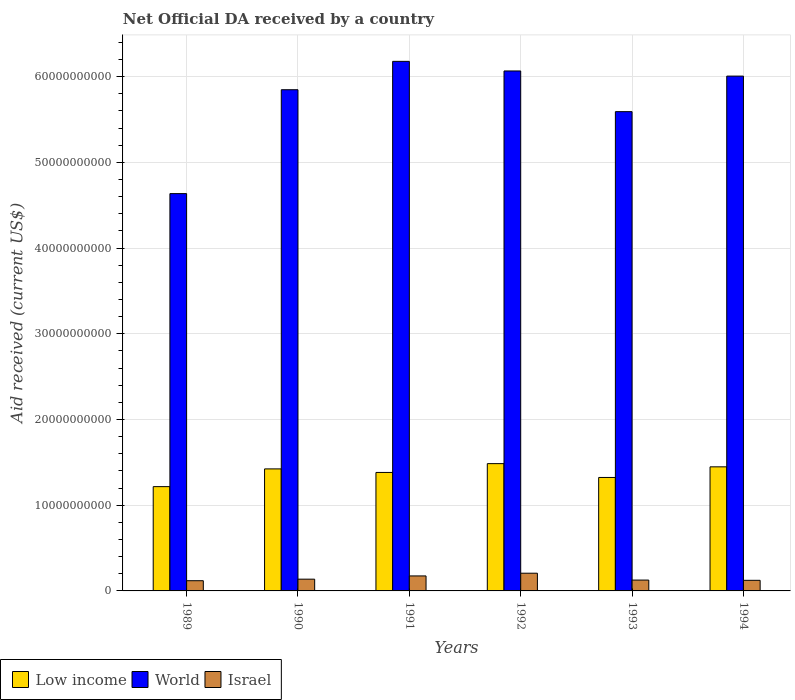How many different coloured bars are there?
Provide a succinct answer. 3. How many groups of bars are there?
Your answer should be very brief. 6. Are the number of bars on each tick of the X-axis equal?
Your answer should be compact. Yes. How many bars are there on the 5th tick from the left?
Provide a succinct answer. 3. How many bars are there on the 3rd tick from the right?
Offer a terse response. 3. In how many cases, is the number of bars for a given year not equal to the number of legend labels?
Your answer should be compact. 0. What is the net official development assistance aid received in Israel in 1991?
Give a very brief answer. 1.75e+09. Across all years, what is the maximum net official development assistance aid received in World?
Your answer should be compact. 6.18e+1. Across all years, what is the minimum net official development assistance aid received in World?
Make the answer very short. 4.64e+1. What is the total net official development assistance aid received in World in the graph?
Offer a very short reply. 3.43e+11. What is the difference between the net official development assistance aid received in World in 1990 and that in 1993?
Give a very brief answer. 2.56e+09. What is the difference between the net official development assistance aid received in Low income in 1991 and the net official development assistance aid received in Israel in 1994?
Your response must be concise. 1.26e+1. What is the average net official development assistance aid received in World per year?
Your answer should be compact. 5.72e+1. In the year 1994, what is the difference between the net official development assistance aid received in Israel and net official development assistance aid received in World?
Provide a succinct answer. -5.88e+1. In how many years, is the net official development assistance aid received in Low income greater than 62000000000 US$?
Provide a succinct answer. 0. What is the ratio of the net official development assistance aid received in Low income in 1989 to that in 1993?
Provide a succinct answer. 0.92. What is the difference between the highest and the second highest net official development assistance aid received in World?
Keep it short and to the point. 1.12e+09. What is the difference between the highest and the lowest net official development assistance aid received in Israel?
Your response must be concise. 8.74e+08. In how many years, is the net official development assistance aid received in World greater than the average net official development assistance aid received in World taken over all years?
Offer a terse response. 4. Is it the case that in every year, the sum of the net official development assistance aid received in World and net official development assistance aid received in Low income is greater than the net official development assistance aid received in Israel?
Offer a very short reply. Yes. Are all the bars in the graph horizontal?
Provide a succinct answer. No. How many years are there in the graph?
Your answer should be compact. 6. Are the values on the major ticks of Y-axis written in scientific E-notation?
Make the answer very short. No. Does the graph contain grids?
Your answer should be very brief. Yes. How are the legend labels stacked?
Offer a very short reply. Horizontal. What is the title of the graph?
Make the answer very short. Net Official DA received by a country. Does "Sao Tome and Principe" appear as one of the legend labels in the graph?
Offer a very short reply. No. What is the label or title of the X-axis?
Provide a short and direct response. Years. What is the label or title of the Y-axis?
Offer a terse response. Aid received (current US$). What is the Aid received (current US$) of Low income in 1989?
Give a very brief answer. 1.22e+1. What is the Aid received (current US$) in World in 1989?
Make the answer very short. 4.64e+1. What is the Aid received (current US$) in Israel in 1989?
Offer a very short reply. 1.19e+09. What is the Aid received (current US$) in Low income in 1990?
Offer a terse response. 1.42e+1. What is the Aid received (current US$) in World in 1990?
Keep it short and to the point. 5.85e+1. What is the Aid received (current US$) in Israel in 1990?
Provide a short and direct response. 1.37e+09. What is the Aid received (current US$) in Low income in 1991?
Your answer should be very brief. 1.38e+1. What is the Aid received (current US$) of World in 1991?
Your answer should be very brief. 6.18e+1. What is the Aid received (current US$) of Israel in 1991?
Ensure brevity in your answer.  1.75e+09. What is the Aid received (current US$) in Low income in 1992?
Make the answer very short. 1.49e+1. What is the Aid received (current US$) of World in 1992?
Make the answer very short. 6.07e+1. What is the Aid received (current US$) in Israel in 1992?
Your answer should be very brief. 2.07e+09. What is the Aid received (current US$) of Low income in 1993?
Provide a short and direct response. 1.32e+1. What is the Aid received (current US$) of World in 1993?
Your answer should be compact. 5.59e+1. What is the Aid received (current US$) of Israel in 1993?
Your answer should be very brief. 1.27e+09. What is the Aid received (current US$) of Low income in 1994?
Provide a short and direct response. 1.45e+1. What is the Aid received (current US$) in World in 1994?
Offer a very short reply. 6.01e+1. What is the Aid received (current US$) of Israel in 1994?
Your answer should be very brief. 1.24e+09. Across all years, what is the maximum Aid received (current US$) in Low income?
Keep it short and to the point. 1.49e+1. Across all years, what is the maximum Aid received (current US$) in World?
Ensure brevity in your answer.  6.18e+1. Across all years, what is the maximum Aid received (current US$) of Israel?
Make the answer very short. 2.07e+09. Across all years, what is the minimum Aid received (current US$) in Low income?
Your answer should be very brief. 1.22e+1. Across all years, what is the minimum Aid received (current US$) in World?
Give a very brief answer. 4.64e+1. Across all years, what is the minimum Aid received (current US$) in Israel?
Your answer should be very brief. 1.19e+09. What is the total Aid received (current US$) in Low income in the graph?
Offer a very short reply. 8.28e+1. What is the total Aid received (current US$) of World in the graph?
Offer a very short reply. 3.43e+11. What is the total Aid received (current US$) of Israel in the graph?
Provide a short and direct response. 8.88e+09. What is the difference between the Aid received (current US$) of Low income in 1989 and that in 1990?
Provide a short and direct response. -2.07e+09. What is the difference between the Aid received (current US$) of World in 1989 and that in 1990?
Your answer should be compact. -1.21e+1. What is the difference between the Aid received (current US$) in Israel in 1989 and that in 1990?
Ensure brevity in your answer.  -1.80e+08. What is the difference between the Aid received (current US$) of Low income in 1989 and that in 1991?
Offer a terse response. -1.66e+09. What is the difference between the Aid received (current US$) in World in 1989 and that in 1991?
Provide a short and direct response. -1.54e+1. What is the difference between the Aid received (current US$) of Israel in 1989 and that in 1991?
Your answer should be compact. -5.58e+08. What is the difference between the Aid received (current US$) in Low income in 1989 and that in 1992?
Ensure brevity in your answer.  -2.68e+09. What is the difference between the Aid received (current US$) in World in 1989 and that in 1992?
Ensure brevity in your answer.  -1.43e+1. What is the difference between the Aid received (current US$) in Israel in 1989 and that in 1992?
Ensure brevity in your answer.  -8.74e+08. What is the difference between the Aid received (current US$) of Low income in 1989 and that in 1993?
Your answer should be very brief. -1.07e+09. What is the difference between the Aid received (current US$) of World in 1989 and that in 1993?
Keep it short and to the point. -9.57e+09. What is the difference between the Aid received (current US$) of Israel in 1989 and that in 1993?
Provide a short and direct response. -7.44e+07. What is the difference between the Aid received (current US$) in Low income in 1989 and that in 1994?
Ensure brevity in your answer.  -2.31e+09. What is the difference between the Aid received (current US$) in World in 1989 and that in 1994?
Offer a terse response. -1.37e+1. What is the difference between the Aid received (current US$) in Israel in 1989 and that in 1994?
Offer a terse response. -4.54e+07. What is the difference between the Aid received (current US$) in Low income in 1990 and that in 1991?
Give a very brief answer. 4.14e+08. What is the difference between the Aid received (current US$) in World in 1990 and that in 1991?
Your answer should be compact. -3.31e+09. What is the difference between the Aid received (current US$) of Israel in 1990 and that in 1991?
Your answer should be compact. -3.78e+08. What is the difference between the Aid received (current US$) in Low income in 1990 and that in 1992?
Make the answer very short. -6.16e+08. What is the difference between the Aid received (current US$) of World in 1990 and that in 1992?
Offer a very short reply. -2.19e+09. What is the difference between the Aid received (current US$) of Israel in 1990 and that in 1992?
Offer a terse response. -6.94e+08. What is the difference between the Aid received (current US$) of Low income in 1990 and that in 1993?
Your answer should be compact. 9.98e+08. What is the difference between the Aid received (current US$) in World in 1990 and that in 1993?
Your response must be concise. 2.56e+09. What is the difference between the Aid received (current US$) of Israel in 1990 and that in 1993?
Your answer should be compact. 1.06e+08. What is the difference between the Aid received (current US$) of Low income in 1990 and that in 1994?
Offer a very short reply. -2.41e+08. What is the difference between the Aid received (current US$) of World in 1990 and that in 1994?
Provide a short and direct response. -1.59e+09. What is the difference between the Aid received (current US$) of Israel in 1990 and that in 1994?
Ensure brevity in your answer.  1.35e+08. What is the difference between the Aid received (current US$) of Low income in 1991 and that in 1992?
Keep it short and to the point. -1.03e+09. What is the difference between the Aid received (current US$) in World in 1991 and that in 1992?
Your answer should be very brief. 1.12e+09. What is the difference between the Aid received (current US$) of Israel in 1991 and that in 1992?
Provide a short and direct response. -3.16e+08. What is the difference between the Aid received (current US$) in Low income in 1991 and that in 1993?
Your answer should be very brief. 5.84e+08. What is the difference between the Aid received (current US$) of World in 1991 and that in 1993?
Keep it short and to the point. 5.87e+09. What is the difference between the Aid received (current US$) in Israel in 1991 and that in 1993?
Your answer should be very brief. 4.83e+08. What is the difference between the Aid received (current US$) of Low income in 1991 and that in 1994?
Provide a short and direct response. -6.55e+08. What is the difference between the Aid received (current US$) in World in 1991 and that in 1994?
Offer a very short reply. 1.72e+09. What is the difference between the Aid received (current US$) in Israel in 1991 and that in 1994?
Give a very brief answer. 5.12e+08. What is the difference between the Aid received (current US$) in Low income in 1992 and that in 1993?
Make the answer very short. 1.61e+09. What is the difference between the Aid received (current US$) of World in 1992 and that in 1993?
Provide a short and direct response. 4.75e+09. What is the difference between the Aid received (current US$) of Israel in 1992 and that in 1993?
Make the answer very short. 8.00e+08. What is the difference between the Aid received (current US$) in Low income in 1992 and that in 1994?
Provide a short and direct response. 3.74e+08. What is the difference between the Aid received (current US$) of World in 1992 and that in 1994?
Your response must be concise. 5.99e+08. What is the difference between the Aid received (current US$) in Israel in 1992 and that in 1994?
Make the answer very short. 8.29e+08. What is the difference between the Aid received (current US$) of Low income in 1993 and that in 1994?
Your answer should be very brief. -1.24e+09. What is the difference between the Aid received (current US$) in World in 1993 and that in 1994?
Make the answer very short. -4.15e+09. What is the difference between the Aid received (current US$) in Israel in 1993 and that in 1994?
Your answer should be very brief. 2.90e+07. What is the difference between the Aid received (current US$) in Low income in 1989 and the Aid received (current US$) in World in 1990?
Your response must be concise. -4.63e+1. What is the difference between the Aid received (current US$) of Low income in 1989 and the Aid received (current US$) of Israel in 1990?
Provide a succinct answer. 1.08e+1. What is the difference between the Aid received (current US$) in World in 1989 and the Aid received (current US$) in Israel in 1990?
Keep it short and to the point. 4.50e+1. What is the difference between the Aid received (current US$) in Low income in 1989 and the Aid received (current US$) in World in 1991?
Make the answer very short. -4.96e+1. What is the difference between the Aid received (current US$) of Low income in 1989 and the Aid received (current US$) of Israel in 1991?
Provide a succinct answer. 1.04e+1. What is the difference between the Aid received (current US$) in World in 1989 and the Aid received (current US$) in Israel in 1991?
Ensure brevity in your answer.  4.46e+1. What is the difference between the Aid received (current US$) in Low income in 1989 and the Aid received (current US$) in World in 1992?
Your response must be concise. -4.85e+1. What is the difference between the Aid received (current US$) of Low income in 1989 and the Aid received (current US$) of Israel in 1992?
Ensure brevity in your answer.  1.01e+1. What is the difference between the Aid received (current US$) in World in 1989 and the Aid received (current US$) in Israel in 1992?
Offer a terse response. 4.43e+1. What is the difference between the Aid received (current US$) in Low income in 1989 and the Aid received (current US$) in World in 1993?
Give a very brief answer. -4.38e+1. What is the difference between the Aid received (current US$) in Low income in 1989 and the Aid received (current US$) in Israel in 1993?
Keep it short and to the point. 1.09e+1. What is the difference between the Aid received (current US$) in World in 1989 and the Aid received (current US$) in Israel in 1993?
Ensure brevity in your answer.  4.51e+1. What is the difference between the Aid received (current US$) in Low income in 1989 and the Aid received (current US$) in World in 1994?
Your answer should be very brief. -4.79e+1. What is the difference between the Aid received (current US$) in Low income in 1989 and the Aid received (current US$) in Israel in 1994?
Make the answer very short. 1.09e+1. What is the difference between the Aid received (current US$) in World in 1989 and the Aid received (current US$) in Israel in 1994?
Provide a succinct answer. 4.51e+1. What is the difference between the Aid received (current US$) of Low income in 1990 and the Aid received (current US$) of World in 1991?
Offer a terse response. -4.76e+1. What is the difference between the Aid received (current US$) in Low income in 1990 and the Aid received (current US$) in Israel in 1991?
Keep it short and to the point. 1.25e+1. What is the difference between the Aid received (current US$) in World in 1990 and the Aid received (current US$) in Israel in 1991?
Ensure brevity in your answer.  5.67e+1. What is the difference between the Aid received (current US$) in Low income in 1990 and the Aid received (current US$) in World in 1992?
Give a very brief answer. -4.64e+1. What is the difference between the Aid received (current US$) of Low income in 1990 and the Aid received (current US$) of Israel in 1992?
Your answer should be very brief. 1.22e+1. What is the difference between the Aid received (current US$) of World in 1990 and the Aid received (current US$) of Israel in 1992?
Make the answer very short. 5.64e+1. What is the difference between the Aid received (current US$) of Low income in 1990 and the Aid received (current US$) of World in 1993?
Provide a succinct answer. -4.17e+1. What is the difference between the Aid received (current US$) in Low income in 1990 and the Aid received (current US$) in Israel in 1993?
Give a very brief answer. 1.30e+1. What is the difference between the Aid received (current US$) in World in 1990 and the Aid received (current US$) in Israel in 1993?
Your response must be concise. 5.72e+1. What is the difference between the Aid received (current US$) of Low income in 1990 and the Aid received (current US$) of World in 1994?
Your answer should be very brief. -4.58e+1. What is the difference between the Aid received (current US$) in Low income in 1990 and the Aid received (current US$) in Israel in 1994?
Provide a succinct answer. 1.30e+1. What is the difference between the Aid received (current US$) of World in 1990 and the Aid received (current US$) of Israel in 1994?
Your answer should be compact. 5.72e+1. What is the difference between the Aid received (current US$) in Low income in 1991 and the Aid received (current US$) in World in 1992?
Provide a succinct answer. -4.68e+1. What is the difference between the Aid received (current US$) in Low income in 1991 and the Aid received (current US$) in Israel in 1992?
Ensure brevity in your answer.  1.18e+1. What is the difference between the Aid received (current US$) of World in 1991 and the Aid received (current US$) of Israel in 1992?
Keep it short and to the point. 5.97e+1. What is the difference between the Aid received (current US$) in Low income in 1991 and the Aid received (current US$) in World in 1993?
Your answer should be very brief. -4.21e+1. What is the difference between the Aid received (current US$) in Low income in 1991 and the Aid received (current US$) in Israel in 1993?
Offer a very short reply. 1.26e+1. What is the difference between the Aid received (current US$) of World in 1991 and the Aid received (current US$) of Israel in 1993?
Give a very brief answer. 6.05e+1. What is the difference between the Aid received (current US$) of Low income in 1991 and the Aid received (current US$) of World in 1994?
Provide a succinct answer. -4.62e+1. What is the difference between the Aid received (current US$) in Low income in 1991 and the Aid received (current US$) in Israel in 1994?
Offer a terse response. 1.26e+1. What is the difference between the Aid received (current US$) in World in 1991 and the Aid received (current US$) in Israel in 1994?
Provide a short and direct response. 6.06e+1. What is the difference between the Aid received (current US$) in Low income in 1992 and the Aid received (current US$) in World in 1993?
Provide a succinct answer. -4.11e+1. What is the difference between the Aid received (current US$) of Low income in 1992 and the Aid received (current US$) of Israel in 1993?
Provide a succinct answer. 1.36e+1. What is the difference between the Aid received (current US$) in World in 1992 and the Aid received (current US$) in Israel in 1993?
Your answer should be compact. 5.94e+1. What is the difference between the Aid received (current US$) in Low income in 1992 and the Aid received (current US$) in World in 1994?
Provide a succinct answer. -4.52e+1. What is the difference between the Aid received (current US$) in Low income in 1992 and the Aid received (current US$) in Israel in 1994?
Your answer should be very brief. 1.36e+1. What is the difference between the Aid received (current US$) of World in 1992 and the Aid received (current US$) of Israel in 1994?
Provide a short and direct response. 5.94e+1. What is the difference between the Aid received (current US$) in Low income in 1993 and the Aid received (current US$) in World in 1994?
Ensure brevity in your answer.  -4.68e+1. What is the difference between the Aid received (current US$) in Low income in 1993 and the Aid received (current US$) in Israel in 1994?
Give a very brief answer. 1.20e+1. What is the difference between the Aid received (current US$) of World in 1993 and the Aid received (current US$) of Israel in 1994?
Keep it short and to the point. 5.47e+1. What is the average Aid received (current US$) in Low income per year?
Offer a terse response. 1.38e+1. What is the average Aid received (current US$) of World per year?
Give a very brief answer. 5.72e+1. What is the average Aid received (current US$) of Israel per year?
Make the answer very short. 1.48e+09. In the year 1989, what is the difference between the Aid received (current US$) of Low income and Aid received (current US$) of World?
Your response must be concise. -3.42e+1. In the year 1989, what is the difference between the Aid received (current US$) of Low income and Aid received (current US$) of Israel?
Ensure brevity in your answer.  1.10e+1. In the year 1989, what is the difference between the Aid received (current US$) of World and Aid received (current US$) of Israel?
Make the answer very short. 4.52e+1. In the year 1990, what is the difference between the Aid received (current US$) of Low income and Aid received (current US$) of World?
Your answer should be very brief. -4.42e+1. In the year 1990, what is the difference between the Aid received (current US$) of Low income and Aid received (current US$) of Israel?
Provide a short and direct response. 1.29e+1. In the year 1990, what is the difference between the Aid received (current US$) of World and Aid received (current US$) of Israel?
Make the answer very short. 5.71e+1. In the year 1991, what is the difference between the Aid received (current US$) of Low income and Aid received (current US$) of World?
Keep it short and to the point. -4.80e+1. In the year 1991, what is the difference between the Aid received (current US$) in Low income and Aid received (current US$) in Israel?
Your answer should be compact. 1.21e+1. In the year 1991, what is the difference between the Aid received (current US$) of World and Aid received (current US$) of Israel?
Provide a short and direct response. 6.00e+1. In the year 1992, what is the difference between the Aid received (current US$) of Low income and Aid received (current US$) of World?
Offer a very short reply. -4.58e+1. In the year 1992, what is the difference between the Aid received (current US$) in Low income and Aid received (current US$) in Israel?
Offer a terse response. 1.28e+1. In the year 1992, what is the difference between the Aid received (current US$) in World and Aid received (current US$) in Israel?
Make the answer very short. 5.86e+1. In the year 1993, what is the difference between the Aid received (current US$) in Low income and Aid received (current US$) in World?
Your answer should be compact. -4.27e+1. In the year 1993, what is the difference between the Aid received (current US$) in Low income and Aid received (current US$) in Israel?
Give a very brief answer. 1.20e+1. In the year 1993, what is the difference between the Aid received (current US$) in World and Aid received (current US$) in Israel?
Offer a very short reply. 5.47e+1. In the year 1994, what is the difference between the Aid received (current US$) of Low income and Aid received (current US$) of World?
Provide a short and direct response. -4.56e+1. In the year 1994, what is the difference between the Aid received (current US$) of Low income and Aid received (current US$) of Israel?
Provide a short and direct response. 1.32e+1. In the year 1994, what is the difference between the Aid received (current US$) in World and Aid received (current US$) in Israel?
Your answer should be very brief. 5.88e+1. What is the ratio of the Aid received (current US$) in Low income in 1989 to that in 1990?
Your answer should be very brief. 0.85. What is the ratio of the Aid received (current US$) in World in 1989 to that in 1990?
Offer a terse response. 0.79. What is the ratio of the Aid received (current US$) in Israel in 1989 to that in 1990?
Your answer should be very brief. 0.87. What is the ratio of the Aid received (current US$) of Low income in 1989 to that in 1991?
Offer a terse response. 0.88. What is the ratio of the Aid received (current US$) of World in 1989 to that in 1991?
Keep it short and to the point. 0.75. What is the ratio of the Aid received (current US$) in Israel in 1989 to that in 1991?
Offer a very short reply. 0.68. What is the ratio of the Aid received (current US$) of Low income in 1989 to that in 1992?
Your response must be concise. 0.82. What is the ratio of the Aid received (current US$) in World in 1989 to that in 1992?
Make the answer very short. 0.76. What is the ratio of the Aid received (current US$) in Israel in 1989 to that in 1992?
Keep it short and to the point. 0.58. What is the ratio of the Aid received (current US$) in Low income in 1989 to that in 1993?
Ensure brevity in your answer.  0.92. What is the ratio of the Aid received (current US$) of World in 1989 to that in 1993?
Give a very brief answer. 0.83. What is the ratio of the Aid received (current US$) of Low income in 1989 to that in 1994?
Your answer should be compact. 0.84. What is the ratio of the Aid received (current US$) in World in 1989 to that in 1994?
Your answer should be compact. 0.77. What is the ratio of the Aid received (current US$) of Israel in 1989 to that in 1994?
Your answer should be compact. 0.96. What is the ratio of the Aid received (current US$) of Low income in 1990 to that in 1991?
Your response must be concise. 1.03. What is the ratio of the Aid received (current US$) in World in 1990 to that in 1991?
Ensure brevity in your answer.  0.95. What is the ratio of the Aid received (current US$) of Israel in 1990 to that in 1991?
Your answer should be compact. 0.78. What is the ratio of the Aid received (current US$) of Low income in 1990 to that in 1992?
Keep it short and to the point. 0.96. What is the ratio of the Aid received (current US$) in World in 1990 to that in 1992?
Make the answer very short. 0.96. What is the ratio of the Aid received (current US$) of Israel in 1990 to that in 1992?
Your answer should be compact. 0.66. What is the ratio of the Aid received (current US$) in Low income in 1990 to that in 1993?
Your answer should be compact. 1.08. What is the ratio of the Aid received (current US$) in World in 1990 to that in 1993?
Ensure brevity in your answer.  1.05. What is the ratio of the Aid received (current US$) of Israel in 1990 to that in 1993?
Keep it short and to the point. 1.08. What is the ratio of the Aid received (current US$) of Low income in 1990 to that in 1994?
Keep it short and to the point. 0.98. What is the ratio of the Aid received (current US$) in World in 1990 to that in 1994?
Offer a terse response. 0.97. What is the ratio of the Aid received (current US$) of Israel in 1990 to that in 1994?
Provide a succinct answer. 1.11. What is the ratio of the Aid received (current US$) in Low income in 1991 to that in 1992?
Keep it short and to the point. 0.93. What is the ratio of the Aid received (current US$) in World in 1991 to that in 1992?
Keep it short and to the point. 1.02. What is the ratio of the Aid received (current US$) of Israel in 1991 to that in 1992?
Make the answer very short. 0.85. What is the ratio of the Aid received (current US$) of Low income in 1991 to that in 1993?
Your answer should be very brief. 1.04. What is the ratio of the Aid received (current US$) of World in 1991 to that in 1993?
Provide a short and direct response. 1.1. What is the ratio of the Aid received (current US$) in Israel in 1991 to that in 1993?
Offer a terse response. 1.38. What is the ratio of the Aid received (current US$) in Low income in 1991 to that in 1994?
Keep it short and to the point. 0.95. What is the ratio of the Aid received (current US$) in World in 1991 to that in 1994?
Your answer should be compact. 1.03. What is the ratio of the Aid received (current US$) of Israel in 1991 to that in 1994?
Your answer should be compact. 1.41. What is the ratio of the Aid received (current US$) of Low income in 1992 to that in 1993?
Give a very brief answer. 1.12. What is the ratio of the Aid received (current US$) in World in 1992 to that in 1993?
Your answer should be compact. 1.08. What is the ratio of the Aid received (current US$) of Israel in 1992 to that in 1993?
Provide a succinct answer. 1.63. What is the ratio of the Aid received (current US$) of Low income in 1992 to that in 1994?
Make the answer very short. 1.03. What is the ratio of the Aid received (current US$) in Israel in 1992 to that in 1994?
Give a very brief answer. 1.67. What is the ratio of the Aid received (current US$) of Low income in 1993 to that in 1994?
Your response must be concise. 0.91. What is the ratio of the Aid received (current US$) of World in 1993 to that in 1994?
Your answer should be compact. 0.93. What is the ratio of the Aid received (current US$) of Israel in 1993 to that in 1994?
Your answer should be very brief. 1.02. What is the difference between the highest and the second highest Aid received (current US$) in Low income?
Provide a succinct answer. 3.74e+08. What is the difference between the highest and the second highest Aid received (current US$) in World?
Offer a terse response. 1.12e+09. What is the difference between the highest and the second highest Aid received (current US$) of Israel?
Your answer should be compact. 3.16e+08. What is the difference between the highest and the lowest Aid received (current US$) of Low income?
Provide a succinct answer. 2.68e+09. What is the difference between the highest and the lowest Aid received (current US$) of World?
Ensure brevity in your answer.  1.54e+1. What is the difference between the highest and the lowest Aid received (current US$) of Israel?
Your answer should be compact. 8.74e+08. 